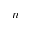Convert formula to latex. <formula><loc_0><loc_0><loc_500><loc_500>n</formula> 